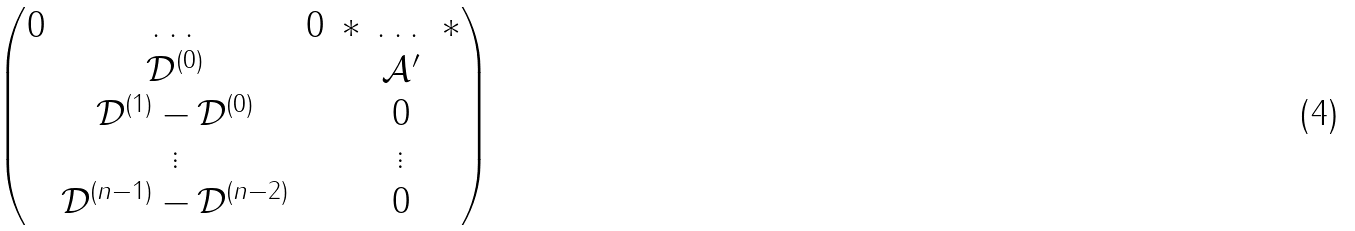<formula> <loc_0><loc_0><loc_500><loc_500>\begin{pmatrix} 0 & \dots & 0 & \ast & \dots & \ast \\ & \mathcal { D } ^ { ( 0 ) } & & & \mathcal { A } ^ { \prime } & \\ & \mathcal { D } ^ { ( 1 ) } - \mathcal { D } ^ { ( 0 ) } & & & 0 & \\ & \vdots & & & \vdots & \\ & \mathcal { D } ^ { ( n - 1 ) } - \mathcal { D } ^ { ( n - 2 ) } & & & 0 & \end{pmatrix}</formula> 